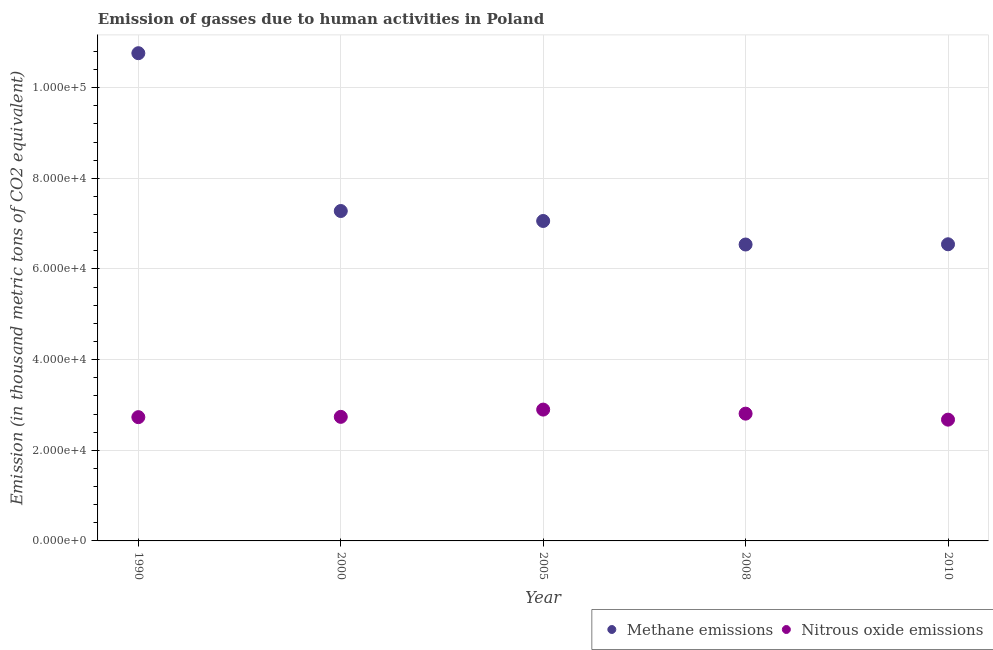How many different coloured dotlines are there?
Keep it short and to the point. 2. What is the amount of nitrous oxide emissions in 2000?
Offer a very short reply. 2.74e+04. Across all years, what is the maximum amount of methane emissions?
Your answer should be very brief. 1.08e+05. Across all years, what is the minimum amount of methane emissions?
Offer a terse response. 6.54e+04. In which year was the amount of nitrous oxide emissions maximum?
Offer a very short reply. 2005. What is the total amount of methane emissions in the graph?
Offer a very short reply. 3.82e+05. What is the difference between the amount of nitrous oxide emissions in 1990 and that in 2008?
Keep it short and to the point. -773.9. What is the difference between the amount of methane emissions in 2000 and the amount of nitrous oxide emissions in 2005?
Your answer should be compact. 4.38e+04. What is the average amount of methane emissions per year?
Keep it short and to the point. 7.64e+04. In the year 2005, what is the difference between the amount of nitrous oxide emissions and amount of methane emissions?
Your answer should be very brief. -4.16e+04. In how many years, is the amount of methane emissions greater than 88000 thousand metric tons?
Your response must be concise. 1. What is the ratio of the amount of nitrous oxide emissions in 1990 to that in 2000?
Ensure brevity in your answer.  1. Is the difference between the amount of methane emissions in 1990 and 2010 greater than the difference between the amount of nitrous oxide emissions in 1990 and 2010?
Provide a succinct answer. Yes. What is the difference between the highest and the second highest amount of nitrous oxide emissions?
Your answer should be compact. 893.5. What is the difference between the highest and the lowest amount of nitrous oxide emissions?
Keep it short and to the point. 2218. Is the sum of the amount of methane emissions in 1990 and 2005 greater than the maximum amount of nitrous oxide emissions across all years?
Provide a succinct answer. Yes. Is the amount of methane emissions strictly less than the amount of nitrous oxide emissions over the years?
Your answer should be very brief. No. How many years are there in the graph?
Make the answer very short. 5. Does the graph contain any zero values?
Make the answer very short. No. Does the graph contain grids?
Your answer should be compact. Yes. What is the title of the graph?
Provide a short and direct response. Emission of gasses due to human activities in Poland. Does "Borrowers" appear as one of the legend labels in the graph?
Your answer should be compact. No. What is the label or title of the Y-axis?
Offer a terse response. Emission (in thousand metric tons of CO2 equivalent). What is the Emission (in thousand metric tons of CO2 equivalent) in Methane emissions in 1990?
Your answer should be compact. 1.08e+05. What is the Emission (in thousand metric tons of CO2 equivalent) of Nitrous oxide emissions in 1990?
Your response must be concise. 2.73e+04. What is the Emission (in thousand metric tons of CO2 equivalent) in Methane emissions in 2000?
Make the answer very short. 7.28e+04. What is the Emission (in thousand metric tons of CO2 equivalent) of Nitrous oxide emissions in 2000?
Offer a terse response. 2.74e+04. What is the Emission (in thousand metric tons of CO2 equivalent) in Methane emissions in 2005?
Your answer should be very brief. 7.06e+04. What is the Emission (in thousand metric tons of CO2 equivalent) in Nitrous oxide emissions in 2005?
Keep it short and to the point. 2.90e+04. What is the Emission (in thousand metric tons of CO2 equivalent) of Methane emissions in 2008?
Your answer should be compact. 6.54e+04. What is the Emission (in thousand metric tons of CO2 equivalent) of Nitrous oxide emissions in 2008?
Provide a short and direct response. 2.81e+04. What is the Emission (in thousand metric tons of CO2 equivalent) of Methane emissions in 2010?
Ensure brevity in your answer.  6.55e+04. What is the Emission (in thousand metric tons of CO2 equivalent) of Nitrous oxide emissions in 2010?
Ensure brevity in your answer.  2.68e+04. Across all years, what is the maximum Emission (in thousand metric tons of CO2 equivalent) of Methane emissions?
Make the answer very short. 1.08e+05. Across all years, what is the maximum Emission (in thousand metric tons of CO2 equivalent) in Nitrous oxide emissions?
Offer a very short reply. 2.90e+04. Across all years, what is the minimum Emission (in thousand metric tons of CO2 equivalent) in Methane emissions?
Provide a short and direct response. 6.54e+04. Across all years, what is the minimum Emission (in thousand metric tons of CO2 equivalent) in Nitrous oxide emissions?
Provide a short and direct response. 2.68e+04. What is the total Emission (in thousand metric tons of CO2 equivalent) in Methane emissions in the graph?
Your answer should be very brief. 3.82e+05. What is the total Emission (in thousand metric tons of CO2 equivalent) of Nitrous oxide emissions in the graph?
Ensure brevity in your answer.  1.38e+05. What is the difference between the Emission (in thousand metric tons of CO2 equivalent) in Methane emissions in 1990 and that in 2000?
Provide a succinct answer. 3.48e+04. What is the difference between the Emission (in thousand metric tons of CO2 equivalent) of Nitrous oxide emissions in 1990 and that in 2000?
Offer a very short reply. -66.8. What is the difference between the Emission (in thousand metric tons of CO2 equivalent) of Methane emissions in 1990 and that in 2005?
Your answer should be very brief. 3.70e+04. What is the difference between the Emission (in thousand metric tons of CO2 equivalent) of Nitrous oxide emissions in 1990 and that in 2005?
Offer a terse response. -1667.4. What is the difference between the Emission (in thousand metric tons of CO2 equivalent) in Methane emissions in 1990 and that in 2008?
Provide a succinct answer. 4.22e+04. What is the difference between the Emission (in thousand metric tons of CO2 equivalent) in Nitrous oxide emissions in 1990 and that in 2008?
Offer a very short reply. -773.9. What is the difference between the Emission (in thousand metric tons of CO2 equivalent) of Methane emissions in 1990 and that in 2010?
Your response must be concise. 4.22e+04. What is the difference between the Emission (in thousand metric tons of CO2 equivalent) in Nitrous oxide emissions in 1990 and that in 2010?
Keep it short and to the point. 550.6. What is the difference between the Emission (in thousand metric tons of CO2 equivalent) of Methane emissions in 2000 and that in 2005?
Give a very brief answer. 2197.9. What is the difference between the Emission (in thousand metric tons of CO2 equivalent) of Nitrous oxide emissions in 2000 and that in 2005?
Make the answer very short. -1600.6. What is the difference between the Emission (in thousand metric tons of CO2 equivalent) in Methane emissions in 2000 and that in 2008?
Provide a short and direct response. 7391.3. What is the difference between the Emission (in thousand metric tons of CO2 equivalent) of Nitrous oxide emissions in 2000 and that in 2008?
Your answer should be compact. -707.1. What is the difference between the Emission (in thousand metric tons of CO2 equivalent) of Methane emissions in 2000 and that in 2010?
Provide a short and direct response. 7338.4. What is the difference between the Emission (in thousand metric tons of CO2 equivalent) of Nitrous oxide emissions in 2000 and that in 2010?
Your answer should be very brief. 617.4. What is the difference between the Emission (in thousand metric tons of CO2 equivalent) in Methane emissions in 2005 and that in 2008?
Provide a succinct answer. 5193.4. What is the difference between the Emission (in thousand metric tons of CO2 equivalent) of Nitrous oxide emissions in 2005 and that in 2008?
Make the answer very short. 893.5. What is the difference between the Emission (in thousand metric tons of CO2 equivalent) in Methane emissions in 2005 and that in 2010?
Provide a short and direct response. 5140.5. What is the difference between the Emission (in thousand metric tons of CO2 equivalent) in Nitrous oxide emissions in 2005 and that in 2010?
Provide a succinct answer. 2218. What is the difference between the Emission (in thousand metric tons of CO2 equivalent) in Methane emissions in 2008 and that in 2010?
Your answer should be very brief. -52.9. What is the difference between the Emission (in thousand metric tons of CO2 equivalent) of Nitrous oxide emissions in 2008 and that in 2010?
Your response must be concise. 1324.5. What is the difference between the Emission (in thousand metric tons of CO2 equivalent) in Methane emissions in 1990 and the Emission (in thousand metric tons of CO2 equivalent) in Nitrous oxide emissions in 2000?
Make the answer very short. 8.02e+04. What is the difference between the Emission (in thousand metric tons of CO2 equivalent) of Methane emissions in 1990 and the Emission (in thousand metric tons of CO2 equivalent) of Nitrous oxide emissions in 2005?
Provide a short and direct response. 7.86e+04. What is the difference between the Emission (in thousand metric tons of CO2 equivalent) in Methane emissions in 1990 and the Emission (in thousand metric tons of CO2 equivalent) in Nitrous oxide emissions in 2008?
Your response must be concise. 7.95e+04. What is the difference between the Emission (in thousand metric tons of CO2 equivalent) in Methane emissions in 1990 and the Emission (in thousand metric tons of CO2 equivalent) in Nitrous oxide emissions in 2010?
Your response must be concise. 8.09e+04. What is the difference between the Emission (in thousand metric tons of CO2 equivalent) in Methane emissions in 2000 and the Emission (in thousand metric tons of CO2 equivalent) in Nitrous oxide emissions in 2005?
Keep it short and to the point. 4.38e+04. What is the difference between the Emission (in thousand metric tons of CO2 equivalent) of Methane emissions in 2000 and the Emission (in thousand metric tons of CO2 equivalent) of Nitrous oxide emissions in 2008?
Provide a succinct answer. 4.47e+04. What is the difference between the Emission (in thousand metric tons of CO2 equivalent) of Methane emissions in 2000 and the Emission (in thousand metric tons of CO2 equivalent) of Nitrous oxide emissions in 2010?
Keep it short and to the point. 4.60e+04. What is the difference between the Emission (in thousand metric tons of CO2 equivalent) of Methane emissions in 2005 and the Emission (in thousand metric tons of CO2 equivalent) of Nitrous oxide emissions in 2008?
Provide a short and direct response. 4.25e+04. What is the difference between the Emission (in thousand metric tons of CO2 equivalent) in Methane emissions in 2005 and the Emission (in thousand metric tons of CO2 equivalent) in Nitrous oxide emissions in 2010?
Provide a short and direct response. 4.38e+04. What is the difference between the Emission (in thousand metric tons of CO2 equivalent) of Methane emissions in 2008 and the Emission (in thousand metric tons of CO2 equivalent) of Nitrous oxide emissions in 2010?
Offer a very short reply. 3.86e+04. What is the average Emission (in thousand metric tons of CO2 equivalent) in Methane emissions per year?
Ensure brevity in your answer.  7.64e+04. What is the average Emission (in thousand metric tons of CO2 equivalent) in Nitrous oxide emissions per year?
Your response must be concise. 2.77e+04. In the year 1990, what is the difference between the Emission (in thousand metric tons of CO2 equivalent) of Methane emissions and Emission (in thousand metric tons of CO2 equivalent) of Nitrous oxide emissions?
Provide a succinct answer. 8.03e+04. In the year 2000, what is the difference between the Emission (in thousand metric tons of CO2 equivalent) in Methane emissions and Emission (in thousand metric tons of CO2 equivalent) in Nitrous oxide emissions?
Your response must be concise. 4.54e+04. In the year 2005, what is the difference between the Emission (in thousand metric tons of CO2 equivalent) in Methane emissions and Emission (in thousand metric tons of CO2 equivalent) in Nitrous oxide emissions?
Keep it short and to the point. 4.16e+04. In the year 2008, what is the difference between the Emission (in thousand metric tons of CO2 equivalent) of Methane emissions and Emission (in thousand metric tons of CO2 equivalent) of Nitrous oxide emissions?
Provide a short and direct response. 3.73e+04. In the year 2010, what is the difference between the Emission (in thousand metric tons of CO2 equivalent) in Methane emissions and Emission (in thousand metric tons of CO2 equivalent) in Nitrous oxide emissions?
Your answer should be compact. 3.87e+04. What is the ratio of the Emission (in thousand metric tons of CO2 equivalent) of Methane emissions in 1990 to that in 2000?
Provide a short and direct response. 1.48. What is the ratio of the Emission (in thousand metric tons of CO2 equivalent) of Nitrous oxide emissions in 1990 to that in 2000?
Provide a short and direct response. 1. What is the ratio of the Emission (in thousand metric tons of CO2 equivalent) of Methane emissions in 1990 to that in 2005?
Offer a terse response. 1.52. What is the ratio of the Emission (in thousand metric tons of CO2 equivalent) of Nitrous oxide emissions in 1990 to that in 2005?
Keep it short and to the point. 0.94. What is the ratio of the Emission (in thousand metric tons of CO2 equivalent) of Methane emissions in 1990 to that in 2008?
Your answer should be compact. 1.65. What is the ratio of the Emission (in thousand metric tons of CO2 equivalent) of Nitrous oxide emissions in 1990 to that in 2008?
Provide a succinct answer. 0.97. What is the ratio of the Emission (in thousand metric tons of CO2 equivalent) in Methane emissions in 1990 to that in 2010?
Provide a short and direct response. 1.64. What is the ratio of the Emission (in thousand metric tons of CO2 equivalent) of Nitrous oxide emissions in 1990 to that in 2010?
Make the answer very short. 1.02. What is the ratio of the Emission (in thousand metric tons of CO2 equivalent) in Methane emissions in 2000 to that in 2005?
Your answer should be very brief. 1.03. What is the ratio of the Emission (in thousand metric tons of CO2 equivalent) in Nitrous oxide emissions in 2000 to that in 2005?
Keep it short and to the point. 0.94. What is the ratio of the Emission (in thousand metric tons of CO2 equivalent) of Methane emissions in 2000 to that in 2008?
Your answer should be very brief. 1.11. What is the ratio of the Emission (in thousand metric tons of CO2 equivalent) in Nitrous oxide emissions in 2000 to that in 2008?
Offer a terse response. 0.97. What is the ratio of the Emission (in thousand metric tons of CO2 equivalent) of Methane emissions in 2000 to that in 2010?
Keep it short and to the point. 1.11. What is the ratio of the Emission (in thousand metric tons of CO2 equivalent) of Nitrous oxide emissions in 2000 to that in 2010?
Your answer should be compact. 1.02. What is the ratio of the Emission (in thousand metric tons of CO2 equivalent) in Methane emissions in 2005 to that in 2008?
Keep it short and to the point. 1.08. What is the ratio of the Emission (in thousand metric tons of CO2 equivalent) of Nitrous oxide emissions in 2005 to that in 2008?
Make the answer very short. 1.03. What is the ratio of the Emission (in thousand metric tons of CO2 equivalent) of Methane emissions in 2005 to that in 2010?
Offer a very short reply. 1.08. What is the ratio of the Emission (in thousand metric tons of CO2 equivalent) of Nitrous oxide emissions in 2005 to that in 2010?
Provide a short and direct response. 1.08. What is the ratio of the Emission (in thousand metric tons of CO2 equivalent) of Methane emissions in 2008 to that in 2010?
Make the answer very short. 1. What is the ratio of the Emission (in thousand metric tons of CO2 equivalent) in Nitrous oxide emissions in 2008 to that in 2010?
Provide a short and direct response. 1.05. What is the difference between the highest and the second highest Emission (in thousand metric tons of CO2 equivalent) of Methane emissions?
Your response must be concise. 3.48e+04. What is the difference between the highest and the second highest Emission (in thousand metric tons of CO2 equivalent) in Nitrous oxide emissions?
Your answer should be very brief. 893.5. What is the difference between the highest and the lowest Emission (in thousand metric tons of CO2 equivalent) in Methane emissions?
Offer a terse response. 4.22e+04. What is the difference between the highest and the lowest Emission (in thousand metric tons of CO2 equivalent) of Nitrous oxide emissions?
Provide a short and direct response. 2218. 